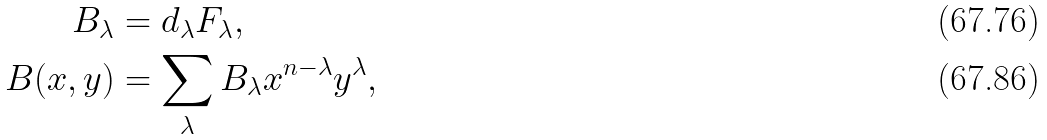Convert formula to latex. <formula><loc_0><loc_0><loc_500><loc_500>B _ { \lambda } & = d _ { \lambda } F _ { \lambda } , \\ B ( x , y ) & = \sum _ { \lambda } B _ { \lambda } x ^ { n - \lambda } y ^ { \lambda } ,</formula> 